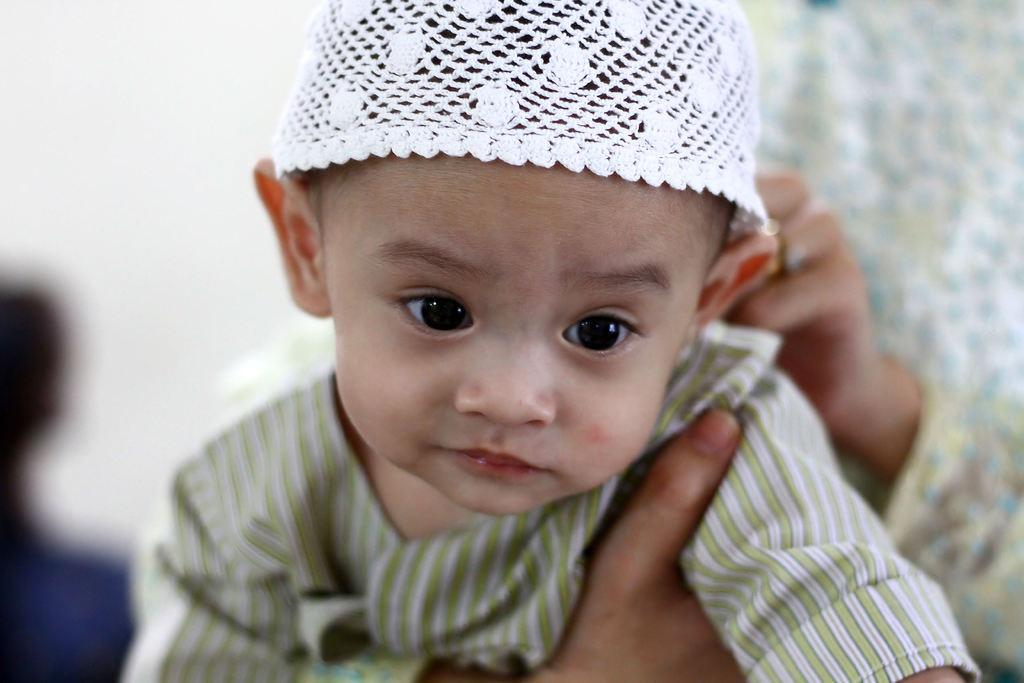What is the main subject of the picture? The main subject of the picture is a child. What is the child wearing on their head? The child is wearing a cap. What color is the cap? The cap is white in color. Who is holding the child in the picture? There is a person holding the child from the back. What type of shoe is the child wearing in the picture? The facts provided do not mention any shoes worn by the child in the picture. --- 